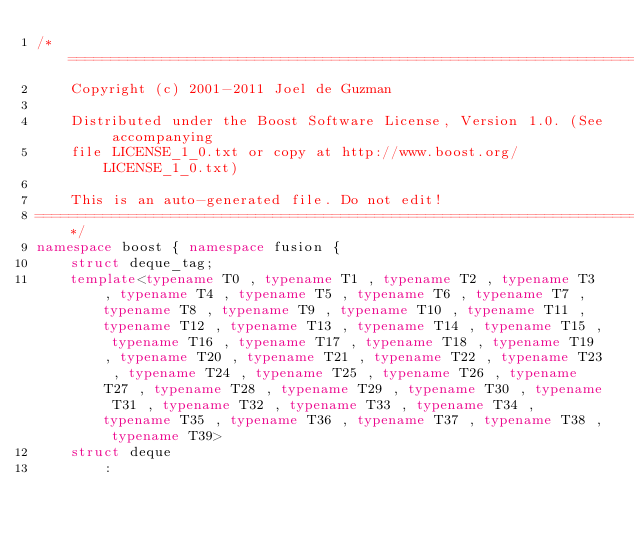<code> <loc_0><loc_0><loc_500><loc_500><_C++_>/*=============================================================================
    Copyright (c) 2001-2011 Joel de Guzman

    Distributed under the Boost Software License, Version 1.0. (See accompanying
    file LICENSE_1_0.txt or copy at http://www.boost.org/LICENSE_1_0.txt)

    This is an auto-generated file. Do not edit!
==============================================================================*/
namespace boost { namespace fusion {
    struct deque_tag;
    template<typename T0 , typename T1 , typename T2 , typename T3 , typename T4 , typename T5 , typename T6 , typename T7 , typename T8 , typename T9 , typename T10 , typename T11 , typename T12 , typename T13 , typename T14 , typename T15 , typename T16 , typename T17 , typename T18 , typename T19 , typename T20 , typename T21 , typename T22 , typename T23 , typename T24 , typename T25 , typename T26 , typename T27 , typename T28 , typename T29 , typename T30 , typename T31 , typename T32 , typename T33 , typename T34 , typename T35 , typename T36 , typename T37 , typename T38 , typename T39>
    struct deque
        :</code> 